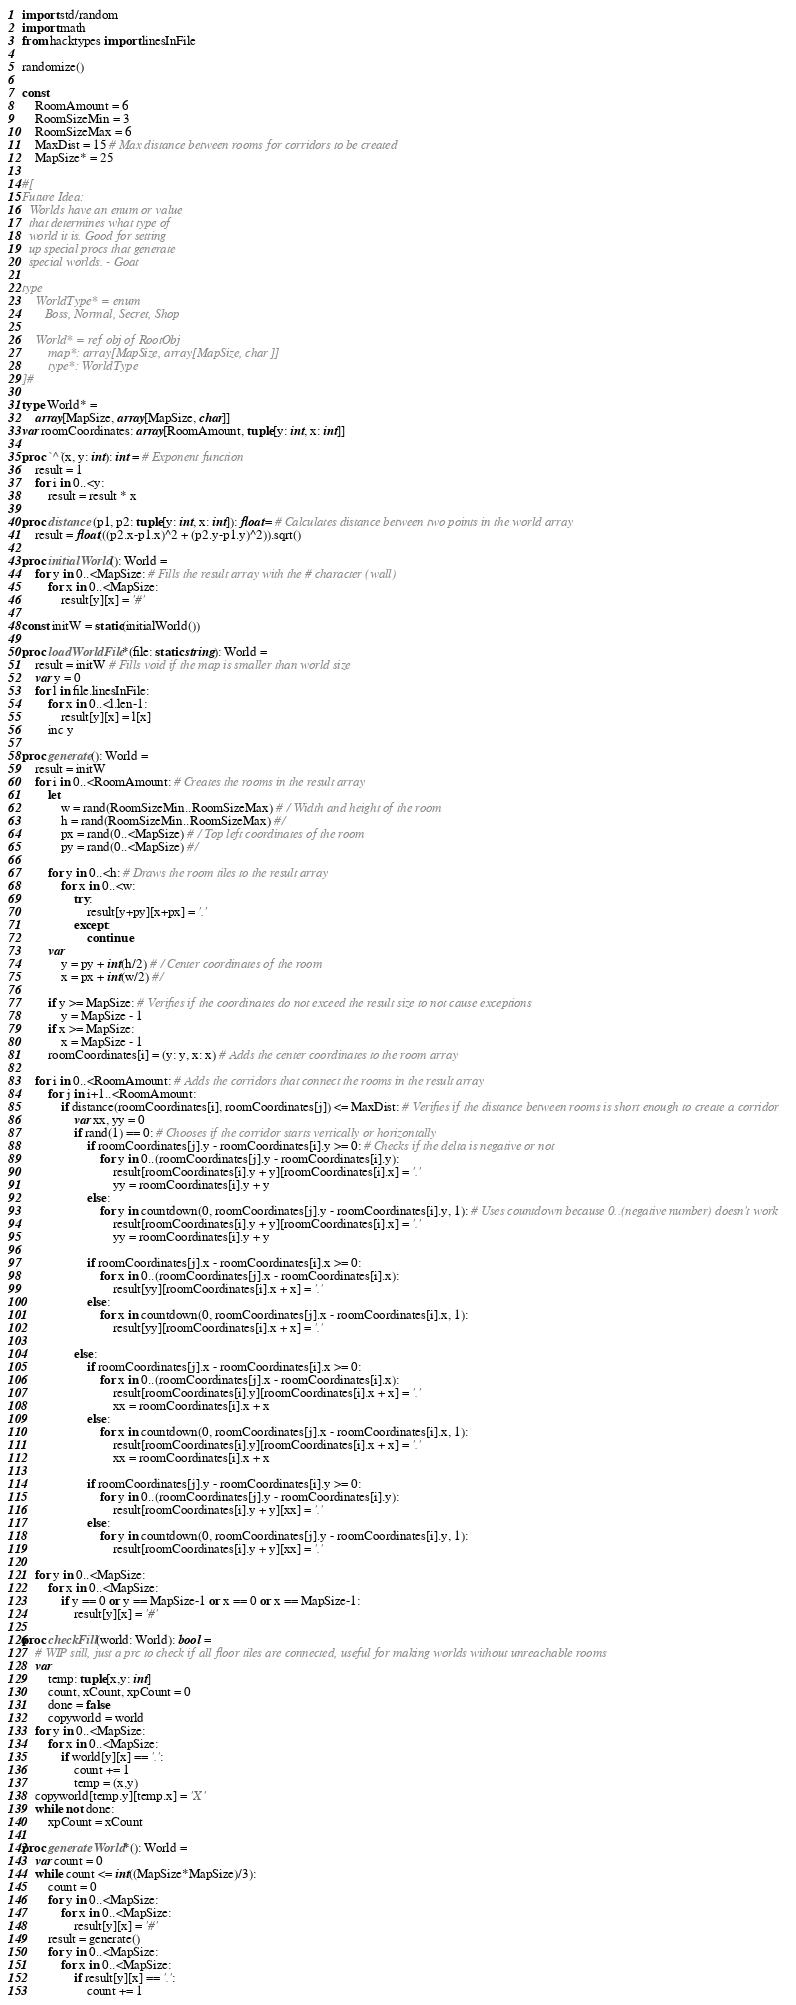<code> <loc_0><loc_0><loc_500><loc_500><_Nim_>import std/random
import math
from hacktypes import linesInFile

randomize()

const 
    RoomAmount = 6
    RoomSizeMin = 3
    RoomSizeMax = 6
    MaxDist = 15 # Max distance between rooms for corridors to be created
    MapSize* = 25

#[
Future Idea:
  Worlds have an enum or value
  that determines what type of
  world it is. Good for setting
  up special procs that generate
  special worlds. - Goat

type
    WorldType* = enum
       Boss, Normal, Secret, Shop

    World* = ref obj of RootObj
        map*: array[MapSize, array[MapSize, char]]
        type*: WorldType
]#

type World* = 
    array[MapSize, array[MapSize, char]]
var roomCoordinates: array[RoomAmount, tuple[y: int, x: int]]

proc `^`(x, y: int): int = # Exponent function
    result = 1
    for i in 0..<y:
        result = result * x

proc distance (p1, p2: tuple[y: int, x: int]): float = # Calculates distance between two points in the world array
    result = float(((p2.x-p1.x)^2 + (p2.y-p1.y)^2)).sqrt()

proc initialWorld(): World =
    for y in 0..<MapSize: # Fills the result array with the # character (wall)
        for x in 0..<MapSize:
            result[y][x] = '#'

const initW = static(initialWorld())

proc loadWorldFile*(file: static string): World =
    result = initW # Fills void if the map is smaller than world size
    var y = 0
    for l in file.linesInFile:
        for x in 0..<l.len-1:
            result[y][x] = l[x]
        inc y

proc generate(): World =
    result = initW
    for i in 0..<RoomAmount: # Creates the rooms in the result array
        let
            w = rand(RoomSizeMin..RoomSizeMax) # / Width and height of the room
            h = rand(RoomSizeMin..RoomSizeMax) #/
            px = rand(0..<MapSize) # / Top left coordinates of the room 
            py = rand(0..<MapSize) #/
        
        for y in 0..<h: # Draws the room tiles to the result array
            for x in 0..<w:
                try:
                    result[y+py][x+px] = '.' 
                except:
                    continue
        var
            y = py + int(h/2) # / Center coordinates of the room
            x = px + int(w/2) #/
        
        if y >= MapSize: # Verifies if the coordinates do not exceed the result size to not cause exceptions
            y = MapSize - 1
        if x >= MapSize:
            x = MapSize - 1
        roomCoordinates[i] = (y: y, x: x) # Adds the center coordinates to the room array

    for i in 0..<RoomAmount: # Adds the corridors that connect the rooms in the result array
        for j in i+1..<RoomAmount:
            if distance(roomCoordinates[i], roomCoordinates[j]) <= MaxDist: # Verifies if the distance between rooms is short enough to create a corridor
                var xx, yy = 0
                if rand(1) == 0: # Chooses if the corridor starts vertically or horizontally
                    if roomCoordinates[j].y - roomCoordinates[i].y >= 0: # Checks if the delta is negative or not
                        for y in 0..(roomCoordinates[j].y - roomCoordinates[i].y):
                            result[roomCoordinates[i].y + y][roomCoordinates[i].x] = '.'
                            yy = roomCoordinates[i].y + y
                    else:
                        for y in countdown(0, roomCoordinates[j].y - roomCoordinates[i].y, 1): # Uses countdown because 0..(negative number) doesn't work
                            result[roomCoordinates[i].y + y][roomCoordinates[i].x] = '.'
                            yy = roomCoordinates[i].y + y

                    if roomCoordinates[j].x - roomCoordinates[i].x >= 0:
                        for x in 0..(roomCoordinates[j].x - roomCoordinates[i].x):
                            result[yy][roomCoordinates[i].x + x] = '.'
                    else:
                        for x in countdown(0, roomCoordinates[j].x - roomCoordinates[i].x, 1):
                            result[yy][roomCoordinates[i].x + x] = '.'

                else:
                    if roomCoordinates[j].x - roomCoordinates[i].x >= 0:
                        for x in 0..(roomCoordinates[j].x - roomCoordinates[i].x):
                            result[roomCoordinates[i].y][roomCoordinates[i].x + x] = '.' 
                            xx = roomCoordinates[i].x + x
                    else:
                        for x in countdown(0, roomCoordinates[j].x - roomCoordinates[i].x, 1):
                            result[roomCoordinates[i].y][roomCoordinates[i].x + x] = '.' 
                            xx = roomCoordinates[i].x + x

                    if roomCoordinates[j].y - roomCoordinates[i].y >= 0:
                        for y in 0..(roomCoordinates[j].y - roomCoordinates[i].y):
                            result[roomCoordinates[i].y + y][xx] = '.'
                    else:
                        for y in countdown(0, roomCoordinates[j].y - roomCoordinates[i].y, 1):
                            result[roomCoordinates[i].y + y][xx] = '.'
    
    for y in 0..<MapSize:
        for x in 0..<MapSize:
            if y == 0 or y == MapSize-1 or x == 0 or x == MapSize-1:
                result[y][x] = '#'

proc checkFill(world: World): bool = 
    # WIP still, just a prc to check if all floor tiles are connected, useful for making worlds without unreachable rooms
    var 
        temp: tuple[x,y: int]
        count, xCount, xpCount = 0
        done = false
        copyworld = world
    for y in 0..<MapSize:
        for x in 0..<MapSize:
            if world[y][x] == '.':
                count += 1
                temp = (x,y)
    copyworld[temp.y][temp.x] = 'X'
    while not done:
        xpCount = xCount

proc generateWorld*(): World =
    var count = 0
    while count <= int((MapSize*MapSize)/3):
        count = 0
        for y in 0..<MapSize:
            for x in 0..<MapSize:
                result[y][x] = '#' 
        result = generate()
        for y in 0..<MapSize:
            for x in 0..<MapSize: 
                if result[y][x] == '.':
                    count += 1
</code> 